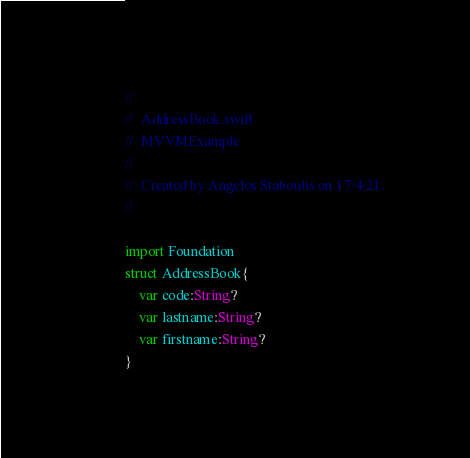<code> <loc_0><loc_0><loc_500><loc_500><_Swift_>//
//  AddressBook.swift
//  MVVMExample
//
//  Created by Angelos Staboulis on 17/4/21.
//

import Foundation
struct AddressBook{
    var code:String?
    var lastname:String?
    var firstname:String?
}
</code> 